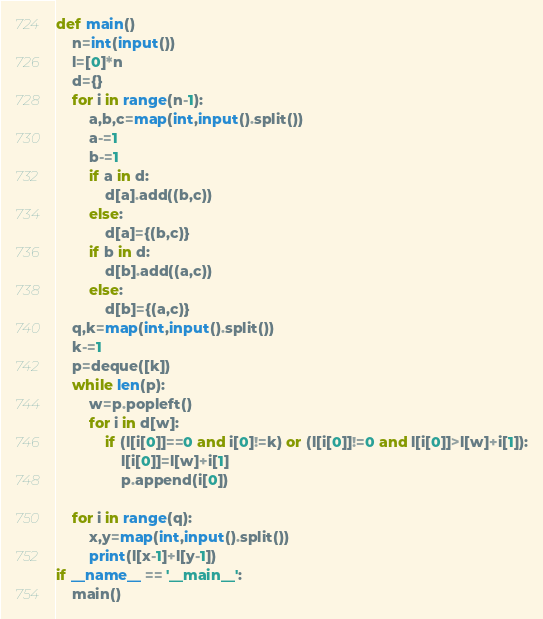<code> <loc_0><loc_0><loc_500><loc_500><_Python_>def main()
    n=int(input())
    l=[0]*n
    d={}
    for i in range(n-1):
        a,b,c=map(int,input().split())
        a-=1
        b-=1
        if a in d:
            d[a].add((b,c))
        else:
            d[a]={(b,c)}
        if b in d:
            d[b].add((a,c))
        else:
            d[b]={(a,c)}
    q,k=map(int,input().split())
    k-=1
    p=deque([k])
    while len(p):
        w=p.popleft()
        for i in d[w]:
            if (l[i[0]]==0 and i[0]!=k) or (l[i[0]]!=0 and l[i[0]]>l[w]+i[1]):
                l[i[0]]=l[w]+i[1]
                p.append(i[0])

    for i in range(q):
        x,y=map(int,input().split())
        print(l[x-1]+l[y-1])
if __name__ == '__main__':
    main()
</code> 